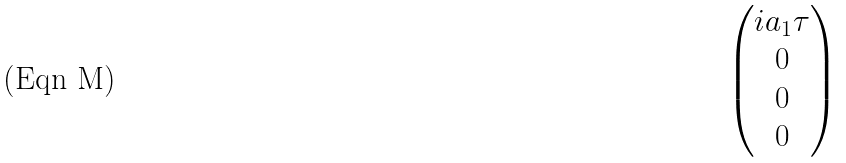<formula> <loc_0><loc_0><loc_500><loc_500>\begin{pmatrix} i a _ { 1 } \tau \\ 0 \\ 0 \\ 0 \end{pmatrix}</formula> 